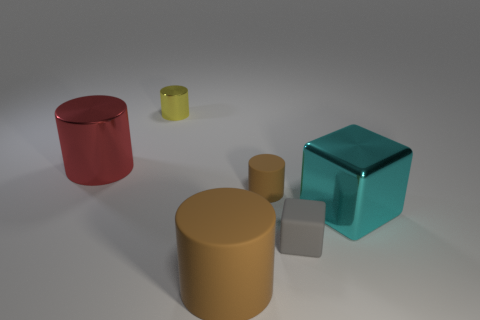Subtract all tiny brown rubber cylinders. How many cylinders are left? 3 Subtract all brown blocks. How many brown cylinders are left? 2 Subtract all red cylinders. How many cylinders are left? 3 Add 1 gray matte blocks. How many objects exist? 7 Subtract all cylinders. How many objects are left? 2 Subtract all gray blocks. Subtract all blue spheres. How many blocks are left? 1 Subtract all big red metal cylinders. Subtract all tiny purple shiny cylinders. How many objects are left? 5 Add 2 blocks. How many blocks are left? 4 Add 2 objects. How many objects exist? 8 Subtract 0 cyan cylinders. How many objects are left? 6 